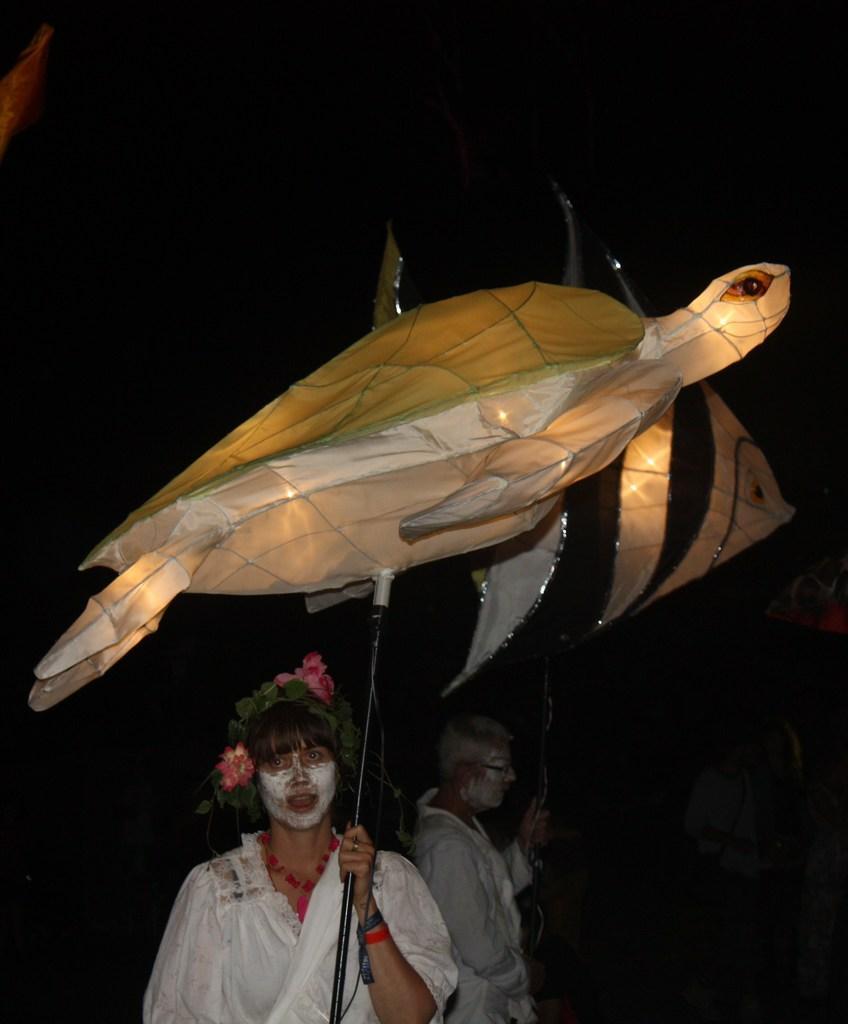In one or two sentences, can you explain what this image depicts? In the center of the image we can see two persons are standing and they are in different costumes. And they are holding some objects, in which we can see sticks attached to the balloons of tortoise and fish. 